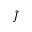Convert formula to latex. <formula><loc_0><loc_0><loc_500><loc_500>\tilde { J }</formula> 